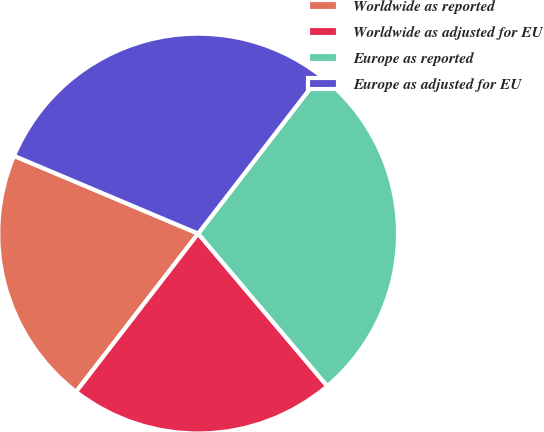Convert chart to OTSL. <chart><loc_0><loc_0><loc_500><loc_500><pie_chart><fcel>Worldwide as reported<fcel>Worldwide as adjusted for EU<fcel>Europe as reported<fcel>Europe as adjusted for EU<nl><fcel>20.9%<fcel>21.64%<fcel>28.36%<fcel>29.1%<nl></chart> 